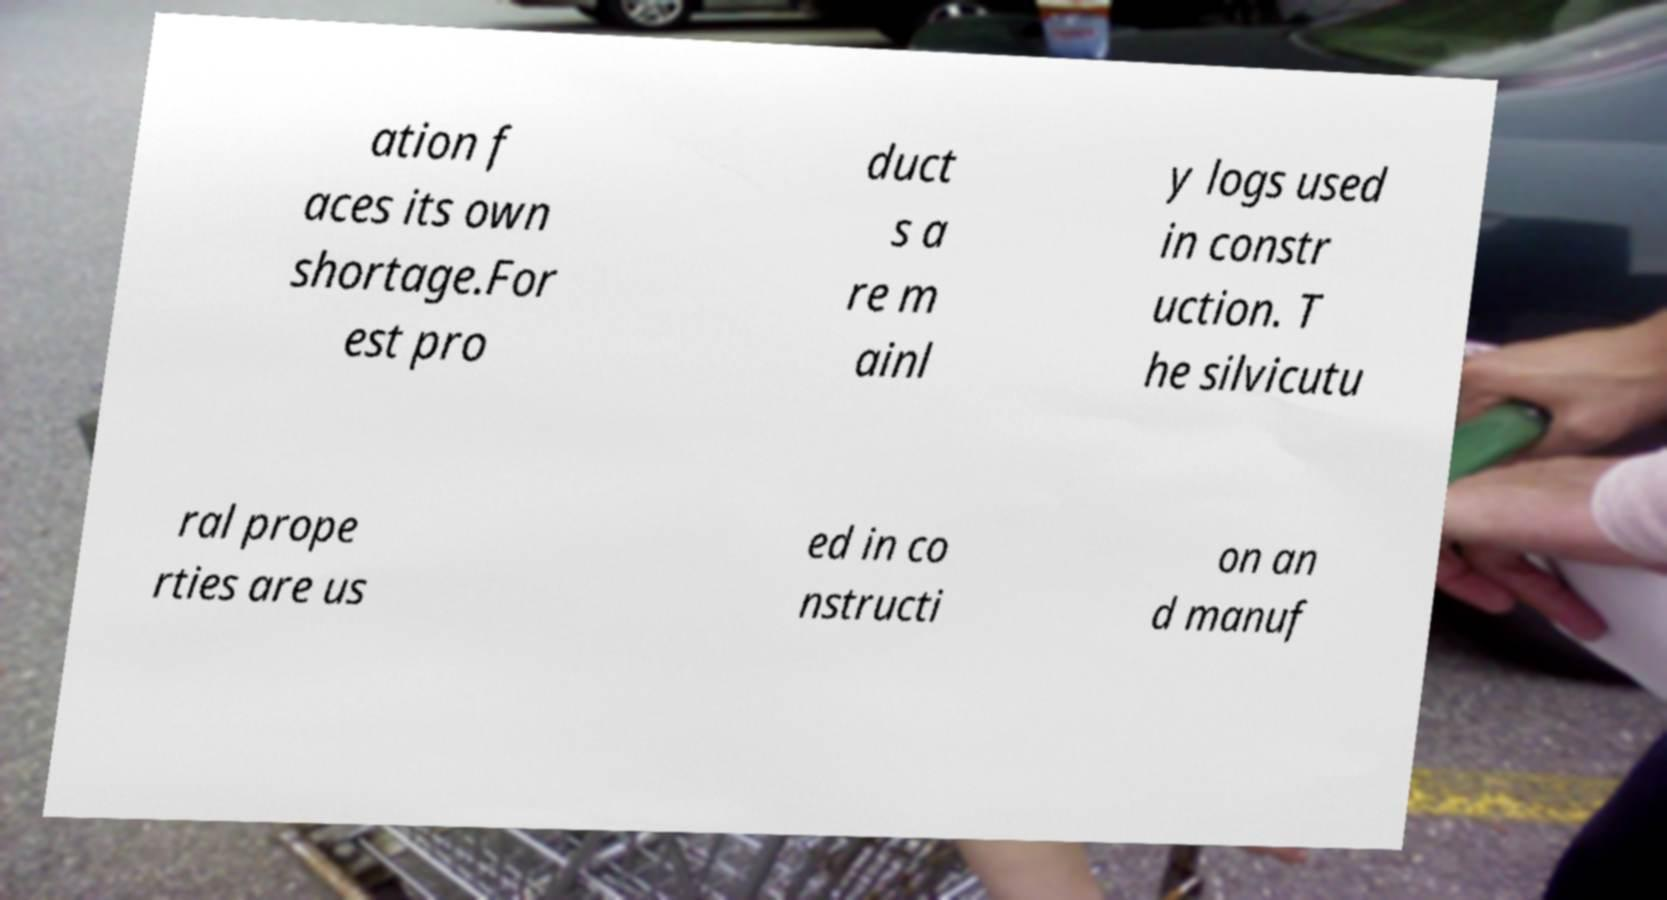What messages or text are displayed in this image? I need them in a readable, typed format. ation f aces its own shortage.For est pro duct s a re m ainl y logs used in constr uction. T he silvicutu ral prope rties are us ed in co nstructi on an d manuf 